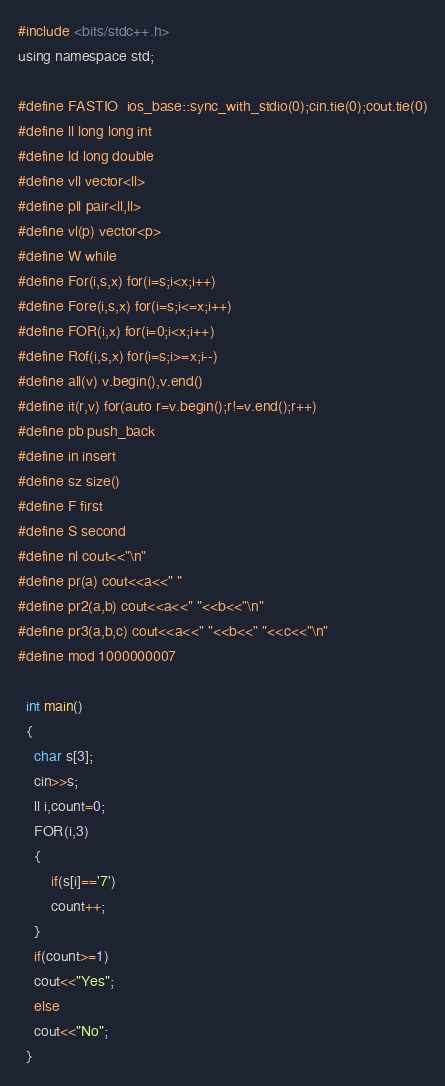Convert code to text. <code><loc_0><loc_0><loc_500><loc_500><_C_>#include <bits/stdc++.h>
using namespace std;
 
#define FASTIO  ios_base::sync_with_stdio(0);cin.tie(0);cout.tie(0)
#define ll long long int
#define ld long double
#define vll vector<ll>
#define pll pair<ll,ll>
#define vl(p) vector<p>
#define W while
#define For(i,s,x) for(i=s;i<x;i++)
#define Fore(i,s,x) for(i=s;i<=x;i++)
#define FOR(i,x) for(i=0;i<x;i++)
#define Rof(i,s,x) for(i=s;i>=x;i--)
#define all(v) v.begin(),v.end()
#define it(r,v) for(auto r=v.begin();r!=v.end();r++)
#define pb push_back
#define in insert
#define sz size()
#define F first
#define S second
#define nl cout<<"\n"
#define pr(a) cout<<a<<" "
#define pr2(a,b) cout<<a<<" "<<b<<"\n"
#define pr3(a,b,c) cout<<a<<" "<<b<<" "<<c<<"\n"
#define mod 1000000007

  int main()
  {
    char s[3];
    cin>>s;
    ll i,count=0;
    FOR(i,3)
    {
        if(s[i]=='7')
        count++;
    }
    if(count>=1)
    cout<<"Yes";
    else
    cout<<"No";
  }</code> 